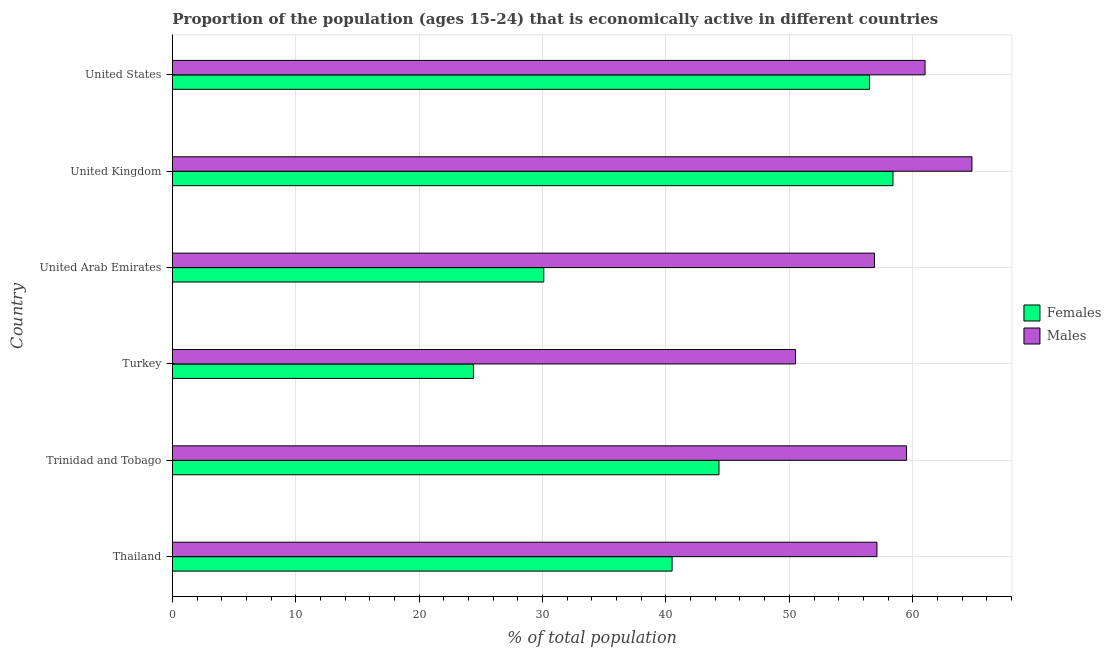How many groups of bars are there?
Keep it short and to the point. 6. Are the number of bars on each tick of the Y-axis equal?
Provide a succinct answer. Yes. How many bars are there on the 1st tick from the top?
Provide a succinct answer. 2. How many bars are there on the 6th tick from the bottom?
Provide a short and direct response. 2. What is the label of the 2nd group of bars from the top?
Your response must be concise. United Kingdom. What is the percentage of economically active female population in Trinidad and Tobago?
Offer a very short reply. 44.3. Across all countries, what is the maximum percentage of economically active female population?
Give a very brief answer. 58.4. Across all countries, what is the minimum percentage of economically active female population?
Your answer should be very brief. 24.4. What is the total percentage of economically active male population in the graph?
Provide a succinct answer. 349.8. What is the difference between the percentage of economically active male population in Thailand and the percentage of economically active female population in United States?
Ensure brevity in your answer.  0.6. What is the average percentage of economically active male population per country?
Your response must be concise. 58.3. What is the difference between the percentage of economically active male population and percentage of economically active female population in United States?
Your answer should be compact. 4.5. In how many countries, is the percentage of economically active female population greater than 62 %?
Provide a succinct answer. 0. What is the ratio of the percentage of economically active female population in Thailand to that in United States?
Offer a very short reply. 0.72. Is the percentage of economically active male population in United Kingdom less than that in United States?
Provide a succinct answer. No. Is the difference between the percentage of economically active female population in Thailand and United States greater than the difference between the percentage of economically active male population in Thailand and United States?
Ensure brevity in your answer.  No. In how many countries, is the percentage of economically active male population greater than the average percentage of economically active male population taken over all countries?
Your answer should be compact. 3. Is the sum of the percentage of economically active male population in Thailand and Turkey greater than the maximum percentage of economically active female population across all countries?
Make the answer very short. Yes. What does the 1st bar from the top in United Arab Emirates represents?
Give a very brief answer. Males. What does the 2nd bar from the bottom in United Kingdom represents?
Make the answer very short. Males. Are all the bars in the graph horizontal?
Offer a very short reply. Yes. How many countries are there in the graph?
Offer a terse response. 6. What is the difference between two consecutive major ticks on the X-axis?
Provide a short and direct response. 10. Are the values on the major ticks of X-axis written in scientific E-notation?
Your response must be concise. No. Does the graph contain any zero values?
Your answer should be compact. No. Where does the legend appear in the graph?
Make the answer very short. Center right. How many legend labels are there?
Offer a very short reply. 2. How are the legend labels stacked?
Provide a succinct answer. Vertical. What is the title of the graph?
Ensure brevity in your answer.  Proportion of the population (ages 15-24) that is economically active in different countries. What is the label or title of the X-axis?
Give a very brief answer. % of total population. What is the % of total population of Females in Thailand?
Your answer should be compact. 40.5. What is the % of total population in Males in Thailand?
Ensure brevity in your answer.  57.1. What is the % of total population in Females in Trinidad and Tobago?
Ensure brevity in your answer.  44.3. What is the % of total population in Males in Trinidad and Tobago?
Your response must be concise. 59.5. What is the % of total population in Females in Turkey?
Keep it short and to the point. 24.4. What is the % of total population in Males in Turkey?
Provide a short and direct response. 50.5. What is the % of total population of Females in United Arab Emirates?
Your answer should be very brief. 30.1. What is the % of total population of Males in United Arab Emirates?
Keep it short and to the point. 56.9. What is the % of total population of Females in United Kingdom?
Give a very brief answer. 58.4. What is the % of total population of Males in United Kingdom?
Your answer should be compact. 64.8. What is the % of total population in Females in United States?
Your answer should be very brief. 56.5. What is the % of total population of Males in United States?
Your response must be concise. 61. Across all countries, what is the maximum % of total population in Females?
Keep it short and to the point. 58.4. Across all countries, what is the maximum % of total population of Males?
Offer a terse response. 64.8. Across all countries, what is the minimum % of total population in Females?
Offer a terse response. 24.4. Across all countries, what is the minimum % of total population in Males?
Provide a succinct answer. 50.5. What is the total % of total population in Females in the graph?
Give a very brief answer. 254.2. What is the total % of total population of Males in the graph?
Provide a short and direct response. 349.8. What is the difference between the % of total population of Males in Thailand and that in Trinidad and Tobago?
Provide a short and direct response. -2.4. What is the difference between the % of total population in Males in Thailand and that in United Arab Emirates?
Provide a short and direct response. 0.2. What is the difference between the % of total population of Females in Thailand and that in United Kingdom?
Your answer should be very brief. -17.9. What is the difference between the % of total population of Males in Thailand and that in United States?
Give a very brief answer. -3.9. What is the difference between the % of total population of Females in Trinidad and Tobago and that in Turkey?
Offer a very short reply. 19.9. What is the difference between the % of total population in Females in Trinidad and Tobago and that in United Arab Emirates?
Give a very brief answer. 14.2. What is the difference between the % of total population in Males in Trinidad and Tobago and that in United Arab Emirates?
Your answer should be compact. 2.6. What is the difference between the % of total population in Females in Trinidad and Tobago and that in United Kingdom?
Offer a terse response. -14.1. What is the difference between the % of total population in Females in Trinidad and Tobago and that in United States?
Make the answer very short. -12.2. What is the difference between the % of total population in Males in Trinidad and Tobago and that in United States?
Offer a very short reply. -1.5. What is the difference between the % of total population in Females in Turkey and that in United Kingdom?
Provide a succinct answer. -34. What is the difference between the % of total population in Males in Turkey and that in United Kingdom?
Your response must be concise. -14.3. What is the difference between the % of total population of Females in Turkey and that in United States?
Ensure brevity in your answer.  -32.1. What is the difference between the % of total population in Males in Turkey and that in United States?
Make the answer very short. -10.5. What is the difference between the % of total population of Females in United Arab Emirates and that in United Kingdom?
Make the answer very short. -28.3. What is the difference between the % of total population of Males in United Arab Emirates and that in United Kingdom?
Provide a short and direct response. -7.9. What is the difference between the % of total population of Females in United Arab Emirates and that in United States?
Provide a succinct answer. -26.4. What is the difference between the % of total population of Males in United Arab Emirates and that in United States?
Give a very brief answer. -4.1. What is the difference between the % of total population in Females in United Kingdom and that in United States?
Ensure brevity in your answer.  1.9. What is the difference between the % of total population of Females in Thailand and the % of total population of Males in Turkey?
Keep it short and to the point. -10. What is the difference between the % of total population of Females in Thailand and the % of total population of Males in United Arab Emirates?
Your response must be concise. -16.4. What is the difference between the % of total population in Females in Thailand and the % of total population in Males in United Kingdom?
Ensure brevity in your answer.  -24.3. What is the difference between the % of total population of Females in Thailand and the % of total population of Males in United States?
Give a very brief answer. -20.5. What is the difference between the % of total population of Females in Trinidad and Tobago and the % of total population of Males in United Arab Emirates?
Keep it short and to the point. -12.6. What is the difference between the % of total population in Females in Trinidad and Tobago and the % of total population in Males in United Kingdom?
Your answer should be very brief. -20.5. What is the difference between the % of total population in Females in Trinidad and Tobago and the % of total population in Males in United States?
Your answer should be compact. -16.7. What is the difference between the % of total population in Females in Turkey and the % of total population in Males in United Arab Emirates?
Keep it short and to the point. -32.5. What is the difference between the % of total population of Females in Turkey and the % of total population of Males in United Kingdom?
Give a very brief answer. -40.4. What is the difference between the % of total population in Females in Turkey and the % of total population in Males in United States?
Offer a terse response. -36.6. What is the difference between the % of total population in Females in United Arab Emirates and the % of total population in Males in United Kingdom?
Offer a terse response. -34.7. What is the difference between the % of total population in Females in United Arab Emirates and the % of total population in Males in United States?
Your answer should be very brief. -30.9. What is the difference between the % of total population in Females in United Kingdom and the % of total population in Males in United States?
Ensure brevity in your answer.  -2.6. What is the average % of total population in Females per country?
Your answer should be compact. 42.37. What is the average % of total population of Males per country?
Keep it short and to the point. 58.3. What is the difference between the % of total population of Females and % of total population of Males in Thailand?
Keep it short and to the point. -16.6. What is the difference between the % of total population in Females and % of total population in Males in Trinidad and Tobago?
Keep it short and to the point. -15.2. What is the difference between the % of total population of Females and % of total population of Males in Turkey?
Provide a succinct answer. -26.1. What is the difference between the % of total population of Females and % of total population of Males in United Arab Emirates?
Make the answer very short. -26.8. What is the difference between the % of total population of Females and % of total population of Males in United Kingdom?
Provide a succinct answer. -6.4. What is the difference between the % of total population of Females and % of total population of Males in United States?
Give a very brief answer. -4.5. What is the ratio of the % of total population of Females in Thailand to that in Trinidad and Tobago?
Ensure brevity in your answer.  0.91. What is the ratio of the % of total population in Males in Thailand to that in Trinidad and Tobago?
Provide a short and direct response. 0.96. What is the ratio of the % of total population of Females in Thailand to that in Turkey?
Offer a very short reply. 1.66. What is the ratio of the % of total population of Males in Thailand to that in Turkey?
Make the answer very short. 1.13. What is the ratio of the % of total population of Females in Thailand to that in United Arab Emirates?
Keep it short and to the point. 1.35. What is the ratio of the % of total population of Males in Thailand to that in United Arab Emirates?
Your response must be concise. 1. What is the ratio of the % of total population of Females in Thailand to that in United Kingdom?
Make the answer very short. 0.69. What is the ratio of the % of total population of Males in Thailand to that in United Kingdom?
Provide a succinct answer. 0.88. What is the ratio of the % of total population in Females in Thailand to that in United States?
Your response must be concise. 0.72. What is the ratio of the % of total population of Males in Thailand to that in United States?
Your answer should be compact. 0.94. What is the ratio of the % of total population of Females in Trinidad and Tobago to that in Turkey?
Provide a succinct answer. 1.82. What is the ratio of the % of total population of Males in Trinidad and Tobago to that in Turkey?
Ensure brevity in your answer.  1.18. What is the ratio of the % of total population of Females in Trinidad and Tobago to that in United Arab Emirates?
Give a very brief answer. 1.47. What is the ratio of the % of total population of Males in Trinidad and Tobago to that in United Arab Emirates?
Make the answer very short. 1.05. What is the ratio of the % of total population of Females in Trinidad and Tobago to that in United Kingdom?
Give a very brief answer. 0.76. What is the ratio of the % of total population in Males in Trinidad and Tobago to that in United Kingdom?
Make the answer very short. 0.92. What is the ratio of the % of total population in Females in Trinidad and Tobago to that in United States?
Give a very brief answer. 0.78. What is the ratio of the % of total population of Males in Trinidad and Tobago to that in United States?
Offer a very short reply. 0.98. What is the ratio of the % of total population in Females in Turkey to that in United Arab Emirates?
Offer a terse response. 0.81. What is the ratio of the % of total population in Males in Turkey to that in United Arab Emirates?
Provide a short and direct response. 0.89. What is the ratio of the % of total population of Females in Turkey to that in United Kingdom?
Your response must be concise. 0.42. What is the ratio of the % of total population in Males in Turkey to that in United Kingdom?
Provide a short and direct response. 0.78. What is the ratio of the % of total population in Females in Turkey to that in United States?
Ensure brevity in your answer.  0.43. What is the ratio of the % of total population in Males in Turkey to that in United States?
Provide a succinct answer. 0.83. What is the ratio of the % of total population in Females in United Arab Emirates to that in United Kingdom?
Keep it short and to the point. 0.52. What is the ratio of the % of total population of Males in United Arab Emirates to that in United Kingdom?
Your answer should be compact. 0.88. What is the ratio of the % of total population of Females in United Arab Emirates to that in United States?
Your answer should be very brief. 0.53. What is the ratio of the % of total population of Males in United Arab Emirates to that in United States?
Make the answer very short. 0.93. What is the ratio of the % of total population of Females in United Kingdom to that in United States?
Provide a short and direct response. 1.03. What is the ratio of the % of total population in Males in United Kingdom to that in United States?
Make the answer very short. 1.06. What is the difference between the highest and the lowest % of total population in Females?
Provide a short and direct response. 34. What is the difference between the highest and the lowest % of total population in Males?
Ensure brevity in your answer.  14.3. 